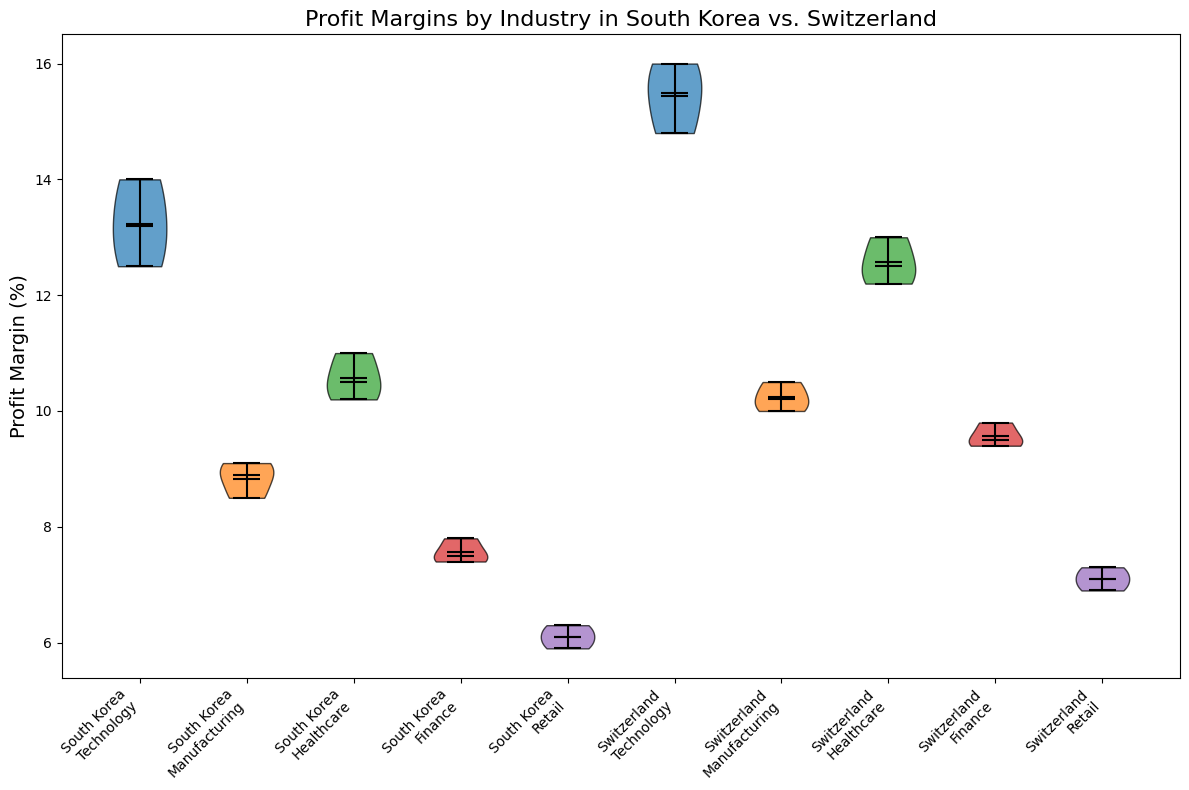What is the industry with the highest median profit margin in South Korea? To determine this, look for the industry in South Korea with the highest center point of the violin plot. The center point indicates the median value.
Answer: Technology Which industry has a wider distribution of profit margins in Switzerland, Finance or Retail? Compare the width of the violin at various points for Finance and Retail in Switzerland. The one with the wider spread at more points has a broader distribution.
Answer: Finance How does the median profit margin of Healthcare compare between South Korea and Switzerland? Look at the center-line in the violin plot for Healthcare in both countries to compare their heights.
Answer: Switzerland has a higher median Which country has a higher maximum profit margin in the Technology industry? Identify the highest point on the violin plot for Technology in both South Korea and Switzerland.
Answer: Switzerland Do both countries have at least one industry where the median profit margin is above 10%? Check if any violin plots have their center line above the 10% mark in both South Korea and Switzerland.
Answer: Yes In which country is the Healthcare industry more profitable on average? Average can often be inferred from the mean point indicated on the violin plot. Compare these points for Healthcare in both countries.
Answer: Switzerland Are the profit margins in the Retail industry generally higher in South Korea or Switzerland? Compare the distribution and center point (median line) of the violin plots for Retail in both countries.
Answer: Switzerland Which industry in South Korea shows the least variability in profit margins? Look for the narrowest violin plot (smallest spread) among the industries in South Korea.
Answer: Manufacturing What is the visual difference in the Manufacturing industry’s profit distribution between South Korea and Switzerland? Compare the shapes of the violin plots to see which has a wider or narrower distribution. The visual difference will highlight variability between the countries.
Answer: Switzerland's distribution is wider Is the median profit margin of Finance industry higher in Switzerland than the highest median in any industry in South Korea? Compare the median line of Finance in Switzerland to the highest median line in any South Korean industry.
Answer: Yes 